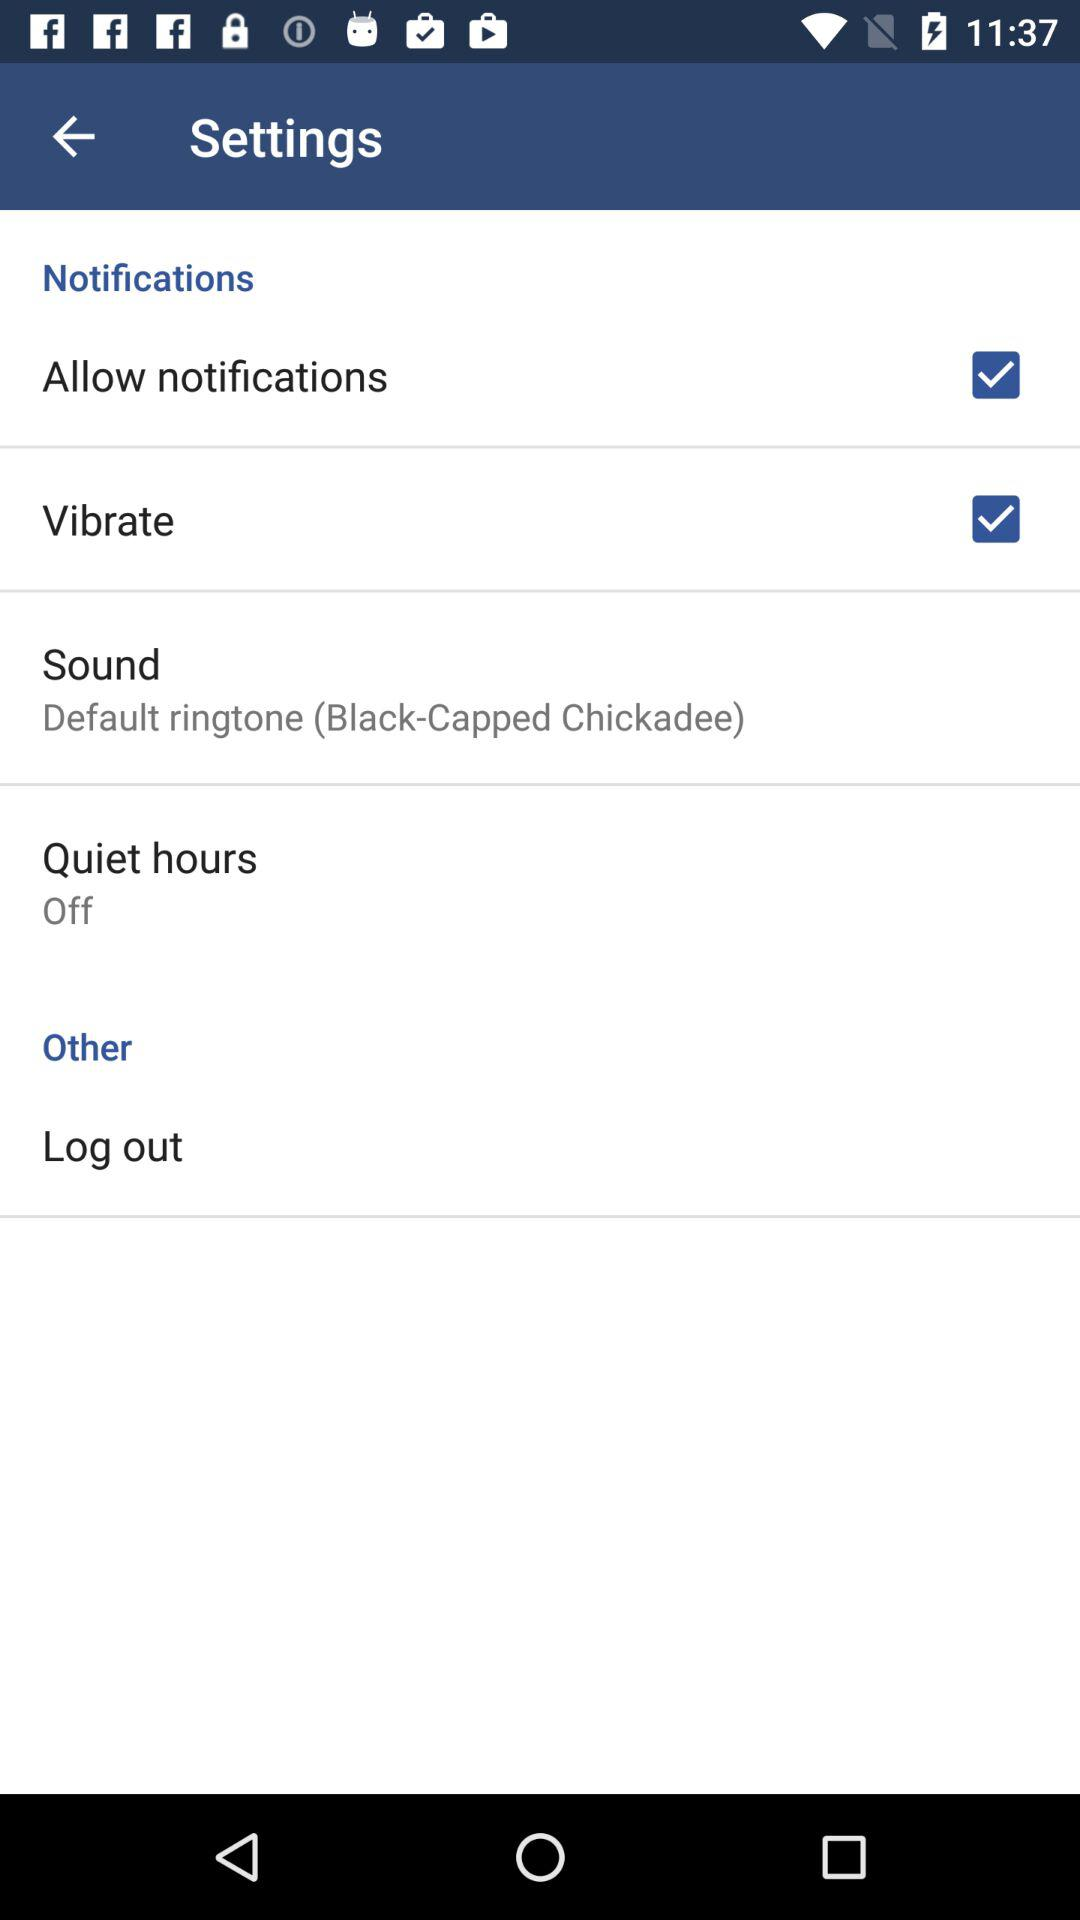Which notifications are checked? The checked notifications are "Allow notifications" and "Vibrate". 